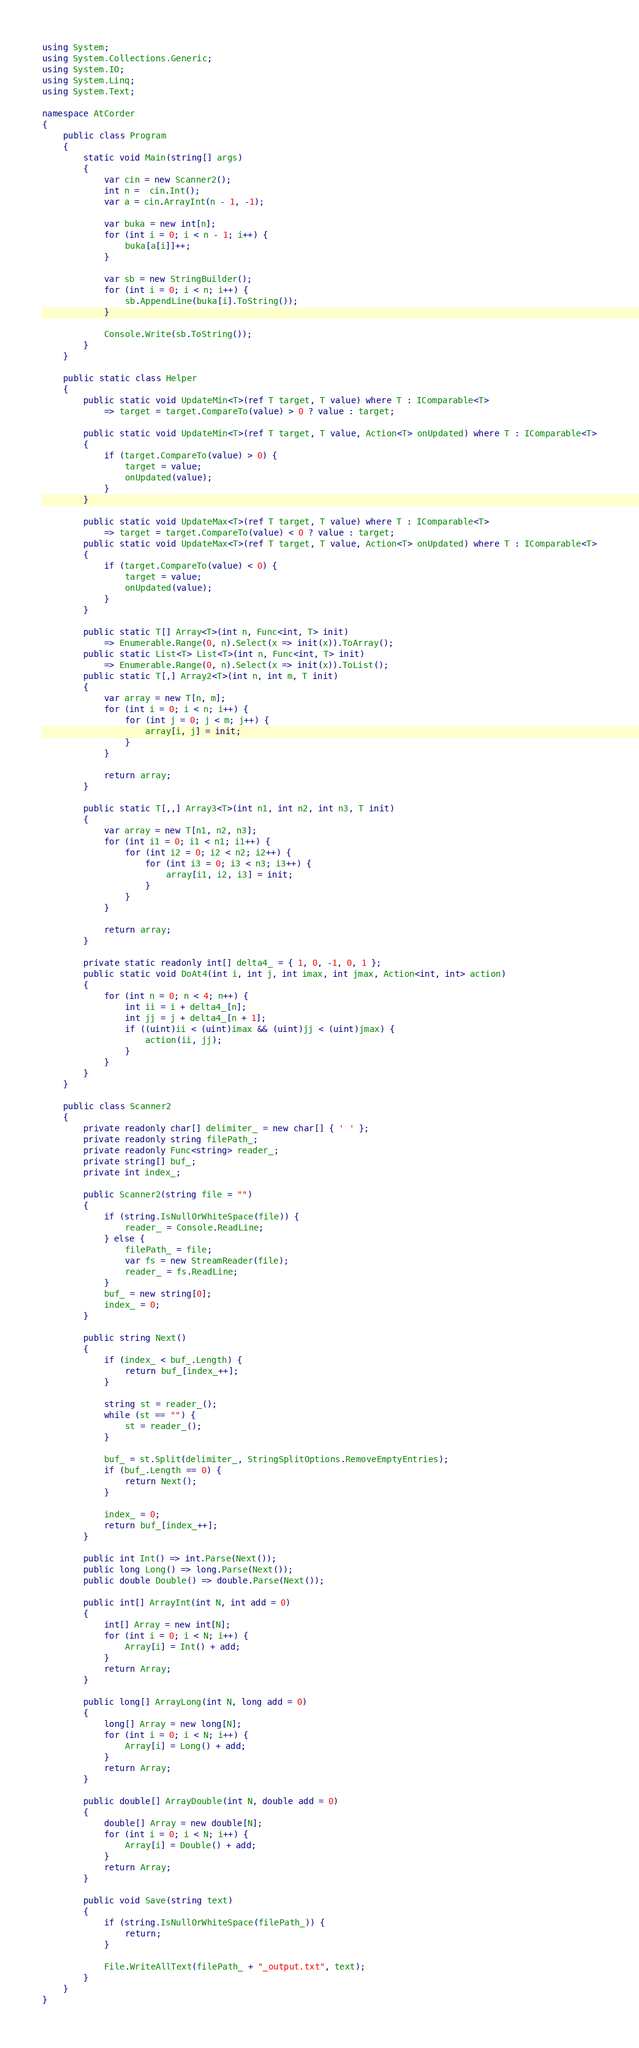Convert code to text. <code><loc_0><loc_0><loc_500><loc_500><_C#_>using System;
using System.Collections.Generic;
using System.IO;
using System.Linq;
using System.Text;

namespace AtCorder
{
	public class Program
	{
		static void Main(string[] args)
		{
			var cin = new Scanner2();
			int n =  cin.Int();
			var a = cin.ArrayInt(n - 1, -1);

			var buka = new int[n];
			for (int i = 0; i < n - 1; i++) {
				buka[a[i]]++;
			}

			var sb = new StringBuilder();
			for (int i = 0; i < n; i++) {
				sb.AppendLine(buka[i].ToString());
			}

			Console.Write(sb.ToString());
		}
	}

	public static class Helper
	{
		public static void UpdateMin<T>(ref T target, T value) where T : IComparable<T>
			=> target = target.CompareTo(value) > 0 ? value : target;

		public static void UpdateMin<T>(ref T target, T value, Action<T> onUpdated) where T : IComparable<T>
		{
			if (target.CompareTo(value) > 0) {
				target = value;
				onUpdated(value);
			}
		}

		public static void UpdateMax<T>(ref T target, T value) where T : IComparable<T>
			=> target = target.CompareTo(value) < 0 ? value : target;
		public static void UpdateMax<T>(ref T target, T value, Action<T> onUpdated) where T : IComparable<T>
		{
			if (target.CompareTo(value) < 0) {
				target = value;
				onUpdated(value);
			}
		}

		public static T[] Array<T>(int n, Func<int, T> init)
			=> Enumerable.Range(0, n).Select(x => init(x)).ToArray();
		public static List<T> List<T>(int n, Func<int, T> init)
			=> Enumerable.Range(0, n).Select(x => init(x)).ToList();
		public static T[,] Array2<T>(int n, int m, T init)
		{
			var array = new T[n, m];
			for (int i = 0; i < n; i++) {
				for (int j = 0; j < m; j++) {
					array[i, j] = init;
				}
			}

			return array;
		}

		public static T[,,] Array3<T>(int n1, int n2, int n3, T init)
		{
			var array = new T[n1, n2, n3];
			for (int i1 = 0; i1 < n1; i1++) {
				for (int i2 = 0; i2 < n2; i2++) {
					for (int i3 = 0; i3 < n3; i3++) {
						array[i1, i2, i3] = init;
					}
				}
			}

			return array;
		}

		private static readonly int[] delta4_ = { 1, 0, -1, 0, 1 };
		public static void DoAt4(int i, int j, int imax, int jmax, Action<int, int> action)
		{
			for (int n = 0; n < 4; n++) {
				int ii = i + delta4_[n];
				int jj = j + delta4_[n + 1];
				if ((uint)ii < (uint)imax && (uint)jj < (uint)jmax) {
					action(ii, jj);
				}
			}
		}
	}

	public class Scanner2
	{
		private readonly char[] delimiter_ = new char[] { ' ' };
		private readonly string filePath_;
		private readonly Func<string> reader_;
		private string[] buf_;
		private int index_;

		public Scanner2(string file = "")
		{
			if (string.IsNullOrWhiteSpace(file)) {
				reader_ = Console.ReadLine;
			} else {
				filePath_ = file;
				var fs = new StreamReader(file);
				reader_ = fs.ReadLine;
			}
			buf_ = new string[0];
			index_ = 0;
		}

		public string Next()
		{
			if (index_ < buf_.Length) {
				return buf_[index_++];
			}

			string st = reader_();
			while (st == "") {
				st = reader_();
			}

			buf_ = st.Split(delimiter_, StringSplitOptions.RemoveEmptyEntries);
			if (buf_.Length == 0) {
				return Next();
			}

			index_ = 0;
			return buf_[index_++];
		}

		public int Int() => int.Parse(Next());
		public long Long() => long.Parse(Next());
		public double Double() => double.Parse(Next());

		public int[] ArrayInt(int N, int add = 0)
		{
			int[] Array = new int[N];
			for (int i = 0; i < N; i++) {
				Array[i] = Int() + add;
			}
			return Array;
		}

		public long[] ArrayLong(int N, long add = 0)
		{
			long[] Array = new long[N];
			for (int i = 0; i < N; i++) {
				Array[i] = Long() + add;
			}
			return Array;
		}

		public double[] ArrayDouble(int N, double add = 0)
		{
			double[] Array = new double[N];
			for (int i = 0; i < N; i++) {
				Array[i] = Double() + add;
			}
			return Array;
		}

		public void Save(string text)
		{
			if (string.IsNullOrWhiteSpace(filePath_)) {
				return;
			}

			File.WriteAllText(filePath_ + "_output.txt", text);
		}
	}
}</code> 